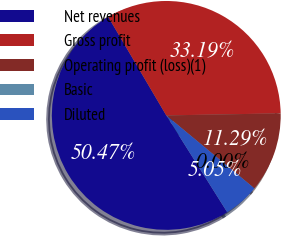Convert chart. <chart><loc_0><loc_0><loc_500><loc_500><pie_chart><fcel>Net revenues<fcel>Gross profit<fcel>Operating profit (loss)(1)<fcel>Basic<fcel>Diluted<nl><fcel>50.47%<fcel>33.19%<fcel>11.29%<fcel>0.0%<fcel>5.05%<nl></chart> 